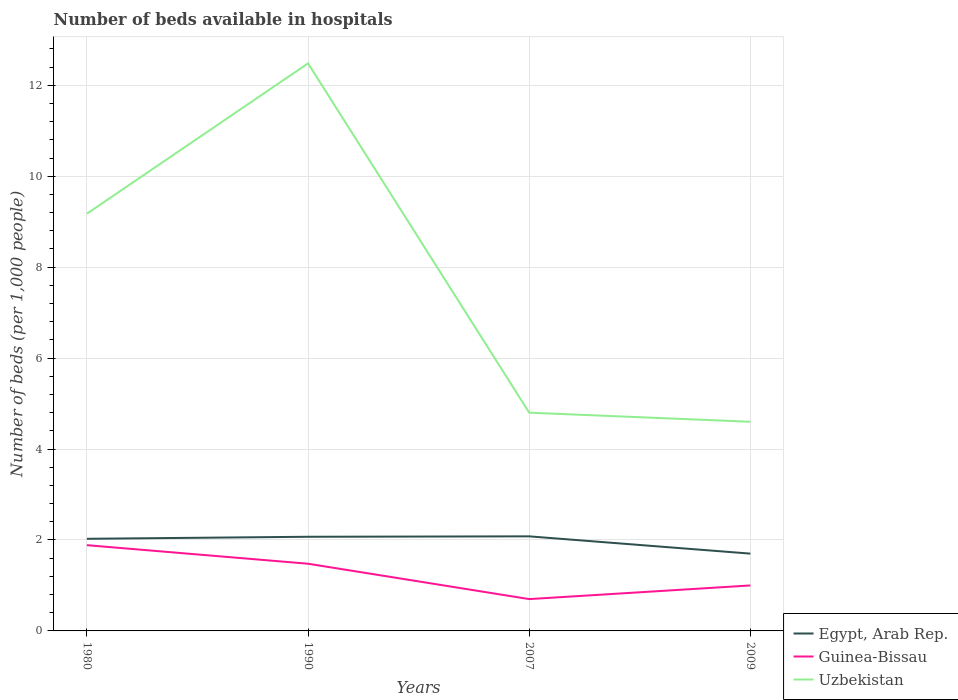How many different coloured lines are there?
Your answer should be very brief. 3. Does the line corresponding to Guinea-Bissau intersect with the line corresponding to Egypt, Arab Rep.?
Your answer should be compact. No. Is the number of lines equal to the number of legend labels?
Provide a succinct answer. Yes. Across all years, what is the maximum number of beds in the hospiatls of in Guinea-Bissau?
Provide a succinct answer. 0.7. In which year was the number of beds in the hospiatls of in Uzbekistan maximum?
Give a very brief answer. 2009. What is the total number of beds in the hospiatls of in Egypt, Arab Rep. in the graph?
Your answer should be very brief. 0.33. What is the difference between the highest and the second highest number of beds in the hospiatls of in Uzbekistan?
Provide a succinct answer. 7.88. What is the difference between the highest and the lowest number of beds in the hospiatls of in Uzbekistan?
Provide a short and direct response. 2. Is the number of beds in the hospiatls of in Uzbekistan strictly greater than the number of beds in the hospiatls of in Egypt, Arab Rep. over the years?
Make the answer very short. No. How many years are there in the graph?
Keep it short and to the point. 4. What is the difference between two consecutive major ticks on the Y-axis?
Your answer should be very brief. 2. Does the graph contain any zero values?
Provide a short and direct response. No. Does the graph contain grids?
Provide a short and direct response. Yes. Where does the legend appear in the graph?
Your answer should be very brief. Bottom right. How many legend labels are there?
Keep it short and to the point. 3. How are the legend labels stacked?
Ensure brevity in your answer.  Vertical. What is the title of the graph?
Make the answer very short. Number of beds available in hospitals. What is the label or title of the X-axis?
Make the answer very short. Years. What is the label or title of the Y-axis?
Ensure brevity in your answer.  Number of beds (per 1,0 people). What is the Number of beds (per 1,000 people) in Egypt, Arab Rep. in 1980?
Your answer should be very brief. 2.03. What is the Number of beds (per 1,000 people) in Guinea-Bissau in 1980?
Your response must be concise. 1.89. What is the Number of beds (per 1,000 people) of Uzbekistan in 1980?
Provide a succinct answer. 9.18. What is the Number of beds (per 1,000 people) in Egypt, Arab Rep. in 1990?
Ensure brevity in your answer.  2.07. What is the Number of beds (per 1,000 people) of Guinea-Bissau in 1990?
Ensure brevity in your answer.  1.48. What is the Number of beds (per 1,000 people) of Uzbekistan in 1990?
Make the answer very short. 12.48. What is the Number of beds (per 1,000 people) of Egypt, Arab Rep. in 2007?
Provide a short and direct response. 2.08. What is the Number of beds (per 1,000 people) in Uzbekistan in 2007?
Make the answer very short. 4.8. What is the Number of beds (per 1,000 people) of Egypt, Arab Rep. in 2009?
Your answer should be compact. 1.7. What is the Number of beds (per 1,000 people) of Uzbekistan in 2009?
Make the answer very short. 4.6. Across all years, what is the maximum Number of beds (per 1,000 people) in Egypt, Arab Rep.?
Provide a short and direct response. 2.08. Across all years, what is the maximum Number of beds (per 1,000 people) in Guinea-Bissau?
Ensure brevity in your answer.  1.89. Across all years, what is the maximum Number of beds (per 1,000 people) of Uzbekistan?
Keep it short and to the point. 12.48. Across all years, what is the minimum Number of beds (per 1,000 people) of Guinea-Bissau?
Your response must be concise. 0.7. What is the total Number of beds (per 1,000 people) in Egypt, Arab Rep. in the graph?
Your answer should be compact. 7.88. What is the total Number of beds (per 1,000 people) of Guinea-Bissau in the graph?
Offer a terse response. 5.06. What is the total Number of beds (per 1,000 people) in Uzbekistan in the graph?
Ensure brevity in your answer.  31.06. What is the difference between the Number of beds (per 1,000 people) of Egypt, Arab Rep. in 1980 and that in 1990?
Your answer should be very brief. -0.04. What is the difference between the Number of beds (per 1,000 people) of Guinea-Bissau in 1980 and that in 1990?
Provide a short and direct response. 0.41. What is the difference between the Number of beds (per 1,000 people) in Uzbekistan in 1980 and that in 1990?
Keep it short and to the point. -3.31. What is the difference between the Number of beds (per 1,000 people) of Egypt, Arab Rep. in 1980 and that in 2007?
Give a very brief answer. -0.05. What is the difference between the Number of beds (per 1,000 people) of Guinea-Bissau in 1980 and that in 2007?
Ensure brevity in your answer.  1.19. What is the difference between the Number of beds (per 1,000 people) in Uzbekistan in 1980 and that in 2007?
Your answer should be compact. 4.38. What is the difference between the Number of beds (per 1,000 people) in Egypt, Arab Rep. in 1980 and that in 2009?
Make the answer very short. 0.33. What is the difference between the Number of beds (per 1,000 people) in Guinea-Bissau in 1980 and that in 2009?
Make the answer very short. 0.89. What is the difference between the Number of beds (per 1,000 people) of Uzbekistan in 1980 and that in 2009?
Your answer should be compact. 4.58. What is the difference between the Number of beds (per 1,000 people) of Egypt, Arab Rep. in 1990 and that in 2007?
Give a very brief answer. -0.01. What is the difference between the Number of beds (per 1,000 people) in Guinea-Bissau in 1990 and that in 2007?
Provide a short and direct response. 0.78. What is the difference between the Number of beds (per 1,000 people) of Uzbekistan in 1990 and that in 2007?
Your answer should be very brief. 7.68. What is the difference between the Number of beds (per 1,000 people) of Egypt, Arab Rep. in 1990 and that in 2009?
Your response must be concise. 0.37. What is the difference between the Number of beds (per 1,000 people) of Guinea-Bissau in 1990 and that in 2009?
Your answer should be very brief. 0.48. What is the difference between the Number of beds (per 1,000 people) of Uzbekistan in 1990 and that in 2009?
Your answer should be compact. 7.88. What is the difference between the Number of beds (per 1,000 people) in Egypt, Arab Rep. in 2007 and that in 2009?
Ensure brevity in your answer.  0.38. What is the difference between the Number of beds (per 1,000 people) of Guinea-Bissau in 2007 and that in 2009?
Offer a terse response. -0.3. What is the difference between the Number of beds (per 1,000 people) of Egypt, Arab Rep. in 1980 and the Number of beds (per 1,000 people) of Guinea-Bissau in 1990?
Give a very brief answer. 0.55. What is the difference between the Number of beds (per 1,000 people) in Egypt, Arab Rep. in 1980 and the Number of beds (per 1,000 people) in Uzbekistan in 1990?
Make the answer very short. -10.46. What is the difference between the Number of beds (per 1,000 people) of Guinea-Bissau in 1980 and the Number of beds (per 1,000 people) of Uzbekistan in 1990?
Your response must be concise. -10.6. What is the difference between the Number of beds (per 1,000 people) in Egypt, Arab Rep. in 1980 and the Number of beds (per 1,000 people) in Guinea-Bissau in 2007?
Your answer should be compact. 1.33. What is the difference between the Number of beds (per 1,000 people) of Egypt, Arab Rep. in 1980 and the Number of beds (per 1,000 people) of Uzbekistan in 2007?
Your response must be concise. -2.77. What is the difference between the Number of beds (per 1,000 people) of Guinea-Bissau in 1980 and the Number of beds (per 1,000 people) of Uzbekistan in 2007?
Your response must be concise. -2.91. What is the difference between the Number of beds (per 1,000 people) of Egypt, Arab Rep. in 1980 and the Number of beds (per 1,000 people) of Guinea-Bissau in 2009?
Make the answer very short. 1.03. What is the difference between the Number of beds (per 1,000 people) in Egypt, Arab Rep. in 1980 and the Number of beds (per 1,000 people) in Uzbekistan in 2009?
Your answer should be very brief. -2.57. What is the difference between the Number of beds (per 1,000 people) of Guinea-Bissau in 1980 and the Number of beds (per 1,000 people) of Uzbekistan in 2009?
Your response must be concise. -2.71. What is the difference between the Number of beds (per 1,000 people) of Egypt, Arab Rep. in 1990 and the Number of beds (per 1,000 people) of Guinea-Bissau in 2007?
Provide a short and direct response. 1.37. What is the difference between the Number of beds (per 1,000 people) of Egypt, Arab Rep. in 1990 and the Number of beds (per 1,000 people) of Uzbekistan in 2007?
Your answer should be very brief. -2.73. What is the difference between the Number of beds (per 1,000 people) of Guinea-Bissau in 1990 and the Number of beds (per 1,000 people) of Uzbekistan in 2007?
Offer a very short reply. -3.32. What is the difference between the Number of beds (per 1,000 people) in Egypt, Arab Rep. in 1990 and the Number of beds (per 1,000 people) in Guinea-Bissau in 2009?
Give a very brief answer. 1.07. What is the difference between the Number of beds (per 1,000 people) in Egypt, Arab Rep. in 1990 and the Number of beds (per 1,000 people) in Uzbekistan in 2009?
Provide a short and direct response. -2.53. What is the difference between the Number of beds (per 1,000 people) of Guinea-Bissau in 1990 and the Number of beds (per 1,000 people) of Uzbekistan in 2009?
Give a very brief answer. -3.12. What is the difference between the Number of beds (per 1,000 people) of Egypt, Arab Rep. in 2007 and the Number of beds (per 1,000 people) of Guinea-Bissau in 2009?
Make the answer very short. 1.08. What is the difference between the Number of beds (per 1,000 people) of Egypt, Arab Rep. in 2007 and the Number of beds (per 1,000 people) of Uzbekistan in 2009?
Offer a terse response. -2.52. What is the difference between the Number of beds (per 1,000 people) of Guinea-Bissau in 2007 and the Number of beds (per 1,000 people) of Uzbekistan in 2009?
Make the answer very short. -3.9. What is the average Number of beds (per 1,000 people) of Egypt, Arab Rep. per year?
Provide a succinct answer. 1.97. What is the average Number of beds (per 1,000 people) of Guinea-Bissau per year?
Provide a succinct answer. 1.27. What is the average Number of beds (per 1,000 people) in Uzbekistan per year?
Offer a very short reply. 7.76. In the year 1980, what is the difference between the Number of beds (per 1,000 people) in Egypt, Arab Rep. and Number of beds (per 1,000 people) in Guinea-Bissau?
Make the answer very short. 0.14. In the year 1980, what is the difference between the Number of beds (per 1,000 people) of Egypt, Arab Rep. and Number of beds (per 1,000 people) of Uzbekistan?
Make the answer very short. -7.15. In the year 1980, what is the difference between the Number of beds (per 1,000 people) in Guinea-Bissau and Number of beds (per 1,000 people) in Uzbekistan?
Ensure brevity in your answer.  -7.29. In the year 1990, what is the difference between the Number of beds (per 1,000 people) of Egypt, Arab Rep. and Number of beds (per 1,000 people) of Guinea-Bissau?
Your response must be concise. 0.59. In the year 1990, what is the difference between the Number of beds (per 1,000 people) in Egypt, Arab Rep. and Number of beds (per 1,000 people) in Uzbekistan?
Your answer should be compact. -10.41. In the year 1990, what is the difference between the Number of beds (per 1,000 people) in Guinea-Bissau and Number of beds (per 1,000 people) in Uzbekistan?
Provide a succinct answer. -11. In the year 2007, what is the difference between the Number of beds (per 1,000 people) in Egypt, Arab Rep. and Number of beds (per 1,000 people) in Guinea-Bissau?
Provide a succinct answer. 1.38. In the year 2007, what is the difference between the Number of beds (per 1,000 people) in Egypt, Arab Rep. and Number of beds (per 1,000 people) in Uzbekistan?
Your answer should be compact. -2.72. In the year 2007, what is the difference between the Number of beds (per 1,000 people) of Guinea-Bissau and Number of beds (per 1,000 people) of Uzbekistan?
Make the answer very short. -4.1. In the year 2009, what is the difference between the Number of beds (per 1,000 people) in Egypt, Arab Rep. and Number of beds (per 1,000 people) in Uzbekistan?
Provide a short and direct response. -2.9. What is the ratio of the Number of beds (per 1,000 people) of Egypt, Arab Rep. in 1980 to that in 1990?
Give a very brief answer. 0.98. What is the ratio of the Number of beds (per 1,000 people) of Guinea-Bissau in 1980 to that in 1990?
Give a very brief answer. 1.28. What is the ratio of the Number of beds (per 1,000 people) in Uzbekistan in 1980 to that in 1990?
Keep it short and to the point. 0.74. What is the ratio of the Number of beds (per 1,000 people) in Egypt, Arab Rep. in 1980 to that in 2007?
Ensure brevity in your answer.  0.97. What is the ratio of the Number of beds (per 1,000 people) in Guinea-Bissau in 1980 to that in 2007?
Provide a short and direct response. 2.69. What is the ratio of the Number of beds (per 1,000 people) in Uzbekistan in 1980 to that in 2007?
Your response must be concise. 1.91. What is the ratio of the Number of beds (per 1,000 people) of Egypt, Arab Rep. in 1980 to that in 2009?
Keep it short and to the point. 1.19. What is the ratio of the Number of beds (per 1,000 people) in Guinea-Bissau in 1980 to that in 2009?
Offer a very short reply. 1.89. What is the ratio of the Number of beds (per 1,000 people) of Uzbekistan in 1980 to that in 2009?
Your answer should be very brief. 1.99. What is the ratio of the Number of beds (per 1,000 people) of Guinea-Bissau in 1990 to that in 2007?
Give a very brief answer. 2.11. What is the ratio of the Number of beds (per 1,000 people) in Uzbekistan in 1990 to that in 2007?
Keep it short and to the point. 2.6. What is the ratio of the Number of beds (per 1,000 people) of Egypt, Arab Rep. in 1990 to that in 2009?
Give a very brief answer. 1.22. What is the ratio of the Number of beds (per 1,000 people) in Guinea-Bissau in 1990 to that in 2009?
Offer a very short reply. 1.48. What is the ratio of the Number of beds (per 1,000 people) in Uzbekistan in 1990 to that in 2009?
Offer a terse response. 2.71. What is the ratio of the Number of beds (per 1,000 people) of Egypt, Arab Rep. in 2007 to that in 2009?
Ensure brevity in your answer.  1.22. What is the ratio of the Number of beds (per 1,000 people) in Uzbekistan in 2007 to that in 2009?
Offer a terse response. 1.04. What is the difference between the highest and the second highest Number of beds (per 1,000 people) of Egypt, Arab Rep.?
Offer a terse response. 0.01. What is the difference between the highest and the second highest Number of beds (per 1,000 people) of Guinea-Bissau?
Keep it short and to the point. 0.41. What is the difference between the highest and the second highest Number of beds (per 1,000 people) of Uzbekistan?
Keep it short and to the point. 3.31. What is the difference between the highest and the lowest Number of beds (per 1,000 people) in Egypt, Arab Rep.?
Your answer should be very brief. 0.38. What is the difference between the highest and the lowest Number of beds (per 1,000 people) in Guinea-Bissau?
Offer a terse response. 1.19. What is the difference between the highest and the lowest Number of beds (per 1,000 people) of Uzbekistan?
Provide a succinct answer. 7.88. 